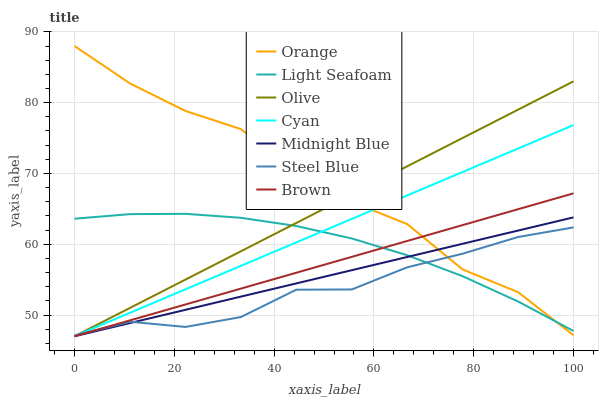Does Steel Blue have the minimum area under the curve?
Answer yes or no. Yes. Does Orange have the maximum area under the curve?
Answer yes or no. Yes. Does Midnight Blue have the minimum area under the curve?
Answer yes or no. No. Does Midnight Blue have the maximum area under the curve?
Answer yes or no. No. Is Brown the smoothest?
Answer yes or no. Yes. Is Orange the roughest?
Answer yes or no. Yes. Is Midnight Blue the smoothest?
Answer yes or no. No. Is Midnight Blue the roughest?
Answer yes or no. No. Does Brown have the lowest value?
Answer yes or no. Yes. Does Steel Blue have the lowest value?
Answer yes or no. No. Does Orange have the highest value?
Answer yes or no. Yes. Does Midnight Blue have the highest value?
Answer yes or no. No. Does Midnight Blue intersect Steel Blue?
Answer yes or no. Yes. Is Midnight Blue less than Steel Blue?
Answer yes or no. No. Is Midnight Blue greater than Steel Blue?
Answer yes or no. No. 